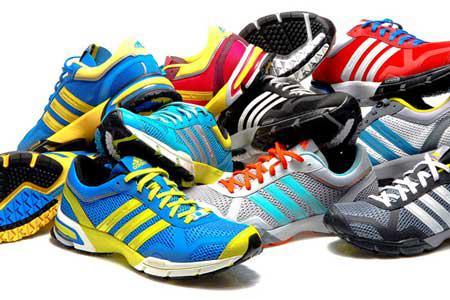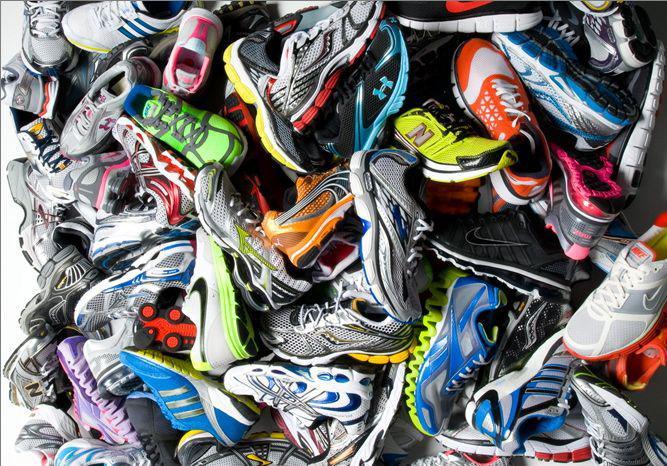The first image is the image on the left, the second image is the image on the right. Considering the images on both sides, is "The shoes are arranged neatly on shelves in one of the iamges." valid? Answer yes or no. No. 